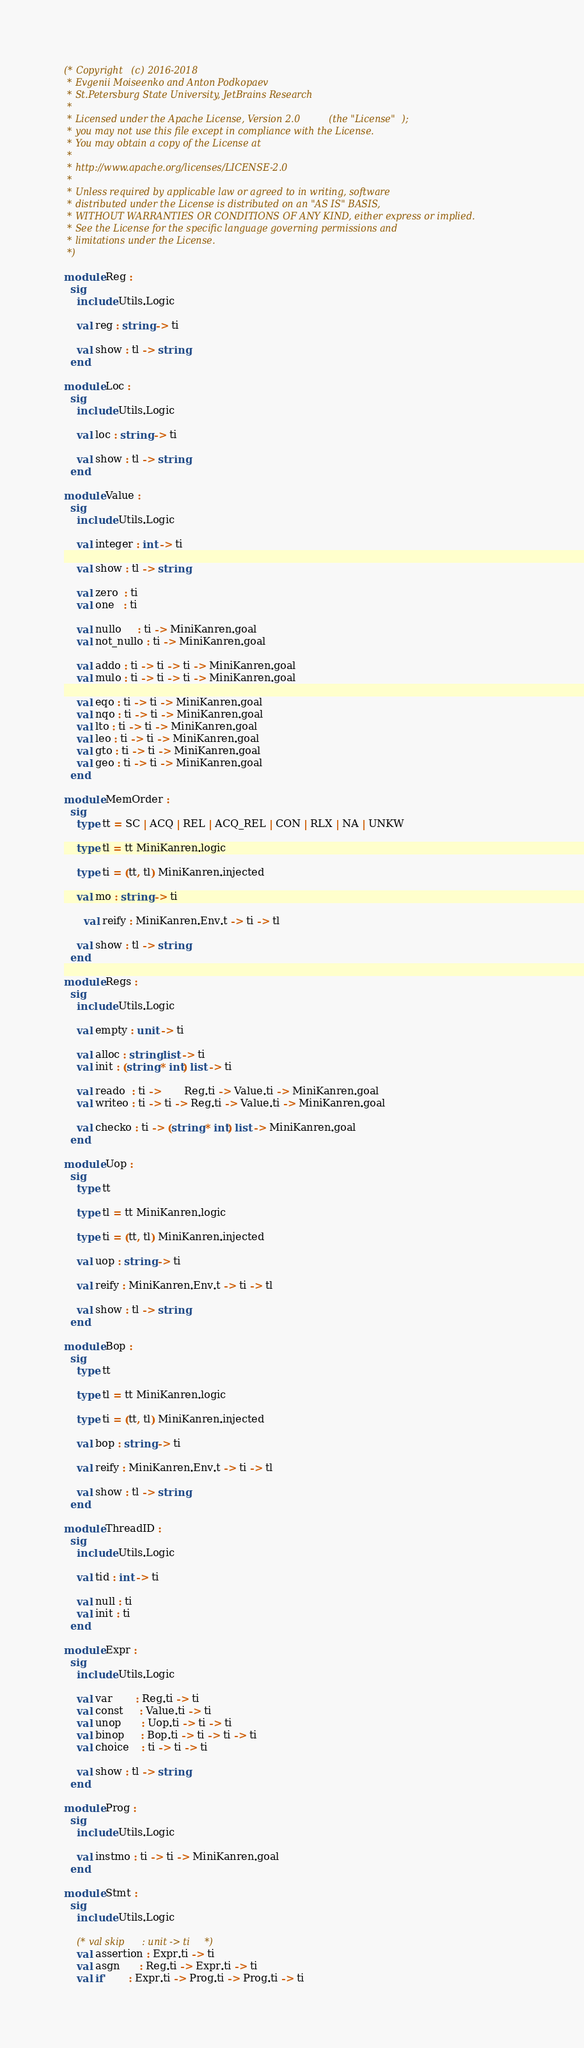<code> <loc_0><loc_0><loc_500><loc_500><_OCaml_>(* Copyright (c) 2016-2018
 * Evgenii Moiseenko and Anton Podkopaev
 * St.Petersburg State University, JetBrains Research
 *
 * Licensed under the Apache License, Version 2.0 (the "License");
 * you may not use this file except in compliance with the License.
 * You may obtain a copy of the License at
 *
 * http://www.apache.org/licenses/LICENSE-2.0
 *
 * Unless required by applicable law or agreed to in writing, software
 * distributed under the License is distributed on an "AS IS" BASIS,
 * WITHOUT WARRANTIES OR CONDITIONS OF ANY KIND, either express or implied.
 * See the License for the specific language governing permissions and
 * limitations under the License.
 *)

module Reg :
  sig
    include Utils.Logic

    val reg : string -> ti

    val show : tl -> string
  end

module Loc :
  sig
    include Utils.Logic

    val loc : string -> ti

    val show : tl -> string
  end

module Value :
  sig
    include Utils.Logic

    val integer : int -> ti

    val show : tl -> string

    val zero  : ti
    val one   : ti

    val nullo     : ti -> MiniKanren.goal
    val not_nullo : ti -> MiniKanren.goal

    val addo : ti -> ti -> ti -> MiniKanren.goal
    val mulo : ti -> ti -> ti -> MiniKanren.goal

    val eqo : ti -> ti -> MiniKanren.goal
    val nqo : ti -> ti -> MiniKanren.goal
    val lto : ti -> ti -> MiniKanren.goal
    val leo : ti -> ti -> MiniKanren.goal
    val gto : ti -> ti -> MiniKanren.goal
    val geo : ti -> ti -> MiniKanren.goal
  end

module MemOrder :
  sig
    type tt = SC | ACQ | REL | ACQ_REL | CON | RLX | NA | UNKW

    type tl = tt MiniKanren.logic

    type ti = (tt, tl) MiniKanren.injected

    val mo : string -> ti

      val reify : MiniKanren.Env.t -> ti -> tl

    val show : tl -> string
  end

module Regs :
  sig
    include Utils.Logic

    val empty : unit -> ti

    val alloc : string list -> ti
    val init : (string * int) list -> ti

    val reado  : ti ->       Reg.ti -> Value.ti -> MiniKanren.goal
    val writeo : ti -> ti -> Reg.ti -> Value.ti -> MiniKanren.goal

    val checko : ti -> (string * int) list -> MiniKanren.goal
  end

module Uop :
  sig
    type tt

    type tl = tt MiniKanren.logic

    type ti = (tt, tl) MiniKanren.injected

    val uop : string -> ti

    val reify : MiniKanren.Env.t -> ti -> tl

    val show : tl -> string
  end

module Bop :
  sig
    type tt

    type tl = tt MiniKanren.logic

    type ti = (tt, tl) MiniKanren.injected

    val bop : string -> ti

    val reify : MiniKanren.Env.t -> ti -> tl

    val show : tl -> string
  end

module ThreadID :
  sig
    include Utils.Logic

    val tid : int -> ti

    val null : ti
    val init : ti
  end

module Expr :
  sig
    include Utils.Logic

    val var       : Reg.ti -> ti
    val const     : Value.ti -> ti
    val unop      : Uop.ti -> ti -> ti
    val binop     : Bop.ti -> ti -> ti -> ti
    val choice    : ti -> ti -> ti

    val show : tl -> string
  end

module Prog :
  sig
    include Utils.Logic

    val instmo : ti -> ti -> MiniKanren.goal
  end

module Stmt :
  sig
    include Utils.Logic

    (* val skip      : unit -> ti *)
    val assertion : Expr.ti -> ti
    val asgn      : Reg.ti -> Expr.ti -> ti
    val if'       : Expr.ti -> Prog.ti -> Prog.ti -> ti</code> 